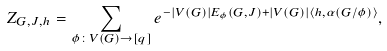<formula> <loc_0><loc_0><loc_500><loc_500>Z _ { G , J , h } = \sum _ { \phi \colon V ( G ) \to [ q ] } e ^ { - | V ( G ) | E _ { \phi } ( G , J ) + | V ( G ) | \langle h , \alpha ( G / \phi ) \rangle } ,</formula> 